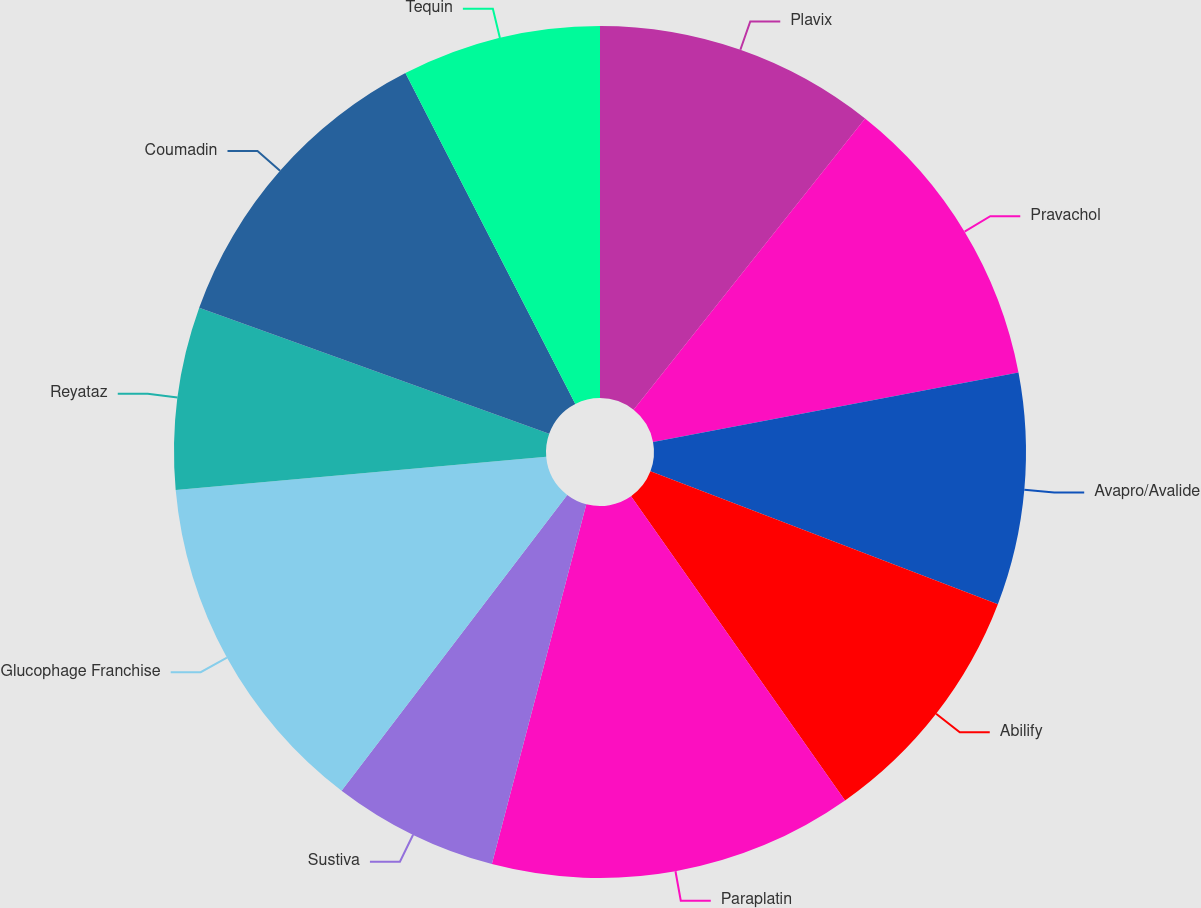<chart> <loc_0><loc_0><loc_500><loc_500><pie_chart><fcel>Plavix<fcel>Pravachol<fcel>Avapro/Avalide<fcel>Abilify<fcel>Paraplatin<fcel>Sustiva<fcel>Glucophage Franchise<fcel>Reyataz<fcel>Coumadin<fcel>Tequin<nl><fcel>10.69%<fcel>11.32%<fcel>8.81%<fcel>9.43%<fcel>13.84%<fcel>6.29%<fcel>13.21%<fcel>6.92%<fcel>11.95%<fcel>7.55%<nl></chart> 